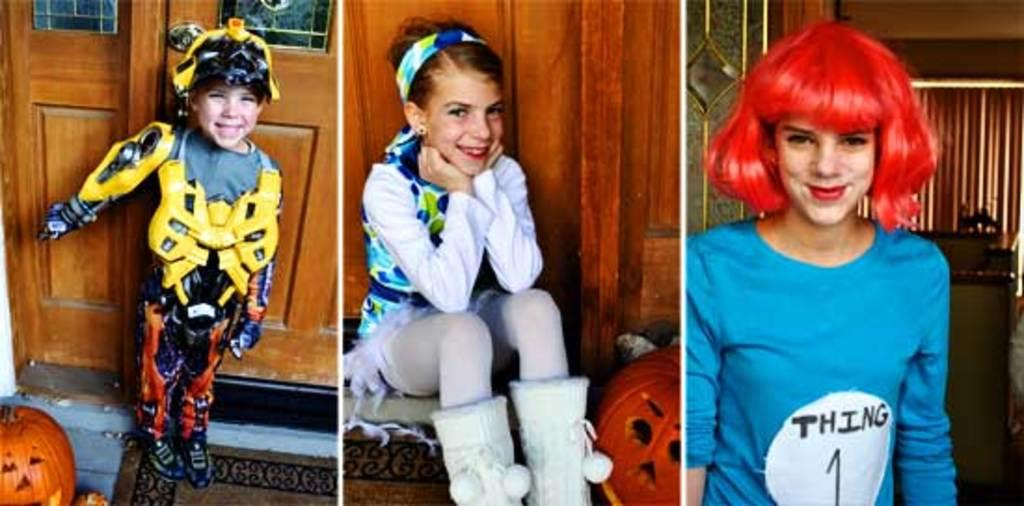What type of artwork is the image? The image is a collage. Can you describe the subjects in the image? There are people in the image. What can be seen beneath the people and other elements in the image? The ground is visible in the image. What season might the image be associated with, based on the objects present? The presence of pumpkins suggests that the image might be associated with fall. What material is visible in the image? There is wood in the image. What is visible behind the main subjects and objects in the image? The background of the image is visible. What type of pot is the queen using to cook in the image? There is no queen or pot present in the image; it is a collage featuring people, pumpkins, and wood. 